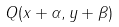Convert formula to latex. <formula><loc_0><loc_0><loc_500><loc_500>Q ( x + \alpha , y + \beta )</formula> 